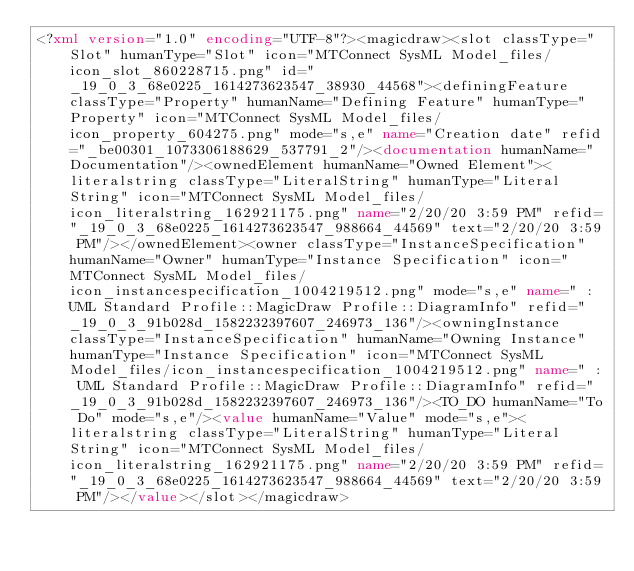<code> <loc_0><loc_0><loc_500><loc_500><_XML_><?xml version="1.0" encoding="UTF-8"?><magicdraw><slot classType="Slot" humanType="Slot" icon="MTConnect SysML Model_files/icon_slot_860228715.png" id="_19_0_3_68e0225_1614273623547_38930_44568"><definingFeature classType="Property" humanName="Defining Feature" humanType="Property" icon="MTConnect SysML Model_files/icon_property_604275.png" mode="s,e" name="Creation date" refid="_be00301_1073306188629_537791_2"/><documentation humanName="Documentation"/><ownedElement humanName="Owned Element"><literalstring classType="LiteralString" humanType="Literal String" icon="MTConnect SysML Model_files/icon_literalstring_162921175.png" name="2/20/20 3:59 PM" refid="_19_0_3_68e0225_1614273623547_988664_44569" text="2/20/20 3:59 PM"/></ownedElement><owner classType="InstanceSpecification" humanName="Owner" humanType="Instance Specification" icon="MTConnect SysML Model_files/icon_instancespecification_1004219512.png" mode="s,e" name=" : UML Standard Profile::MagicDraw Profile::DiagramInfo" refid="_19_0_3_91b028d_1582232397607_246973_136"/><owningInstance classType="InstanceSpecification" humanName="Owning Instance" humanType="Instance Specification" icon="MTConnect SysML Model_files/icon_instancespecification_1004219512.png" name=" : UML Standard Profile::MagicDraw Profile::DiagramInfo" refid="_19_0_3_91b028d_1582232397607_246973_136"/><TO_DO humanName="To Do" mode="s,e"/><value humanName="Value" mode="s,e"><literalstring classType="LiteralString" humanType="Literal String" icon="MTConnect SysML Model_files/icon_literalstring_162921175.png" name="2/20/20 3:59 PM" refid="_19_0_3_68e0225_1614273623547_988664_44569" text="2/20/20 3:59 PM"/></value></slot></magicdraw></code> 